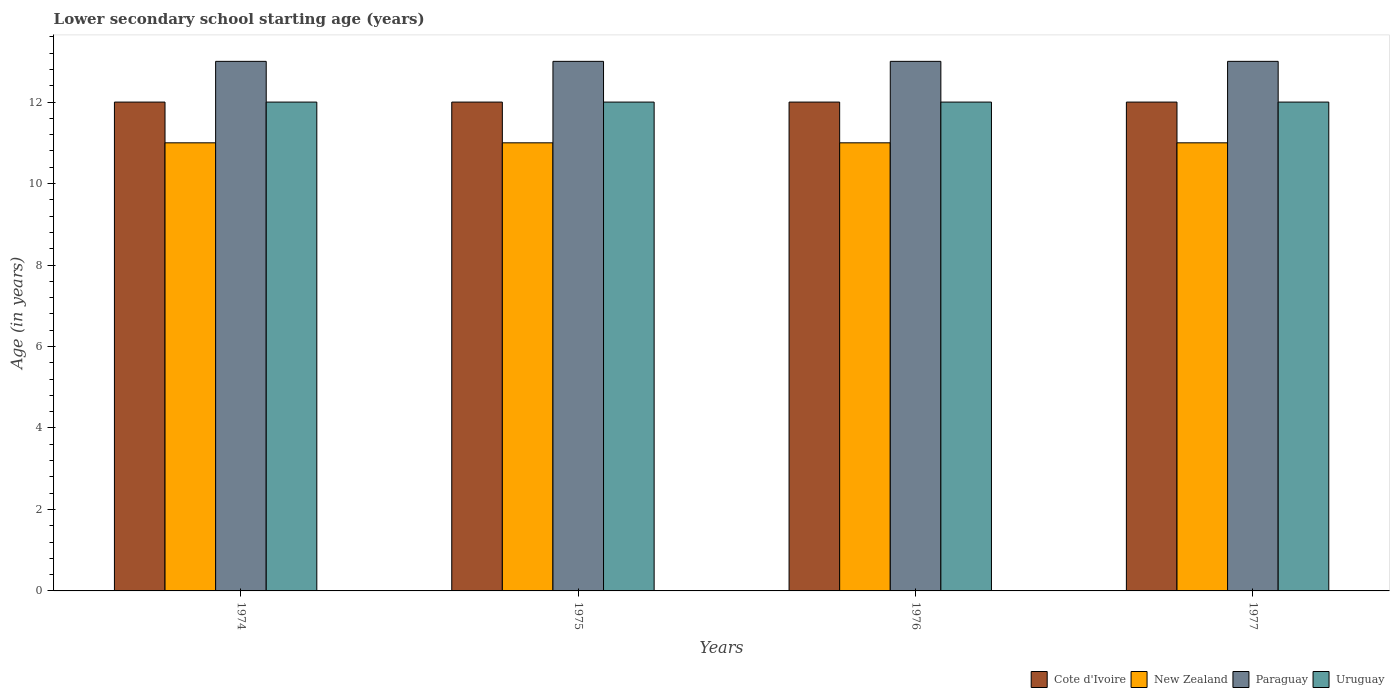How many groups of bars are there?
Provide a succinct answer. 4. Are the number of bars per tick equal to the number of legend labels?
Provide a succinct answer. Yes. Are the number of bars on each tick of the X-axis equal?
Offer a very short reply. Yes. How many bars are there on the 4th tick from the right?
Make the answer very short. 4. In how many cases, is the number of bars for a given year not equal to the number of legend labels?
Make the answer very short. 0. What is the lower secondary school starting age of children in New Zealand in 1977?
Provide a succinct answer. 11. Across all years, what is the maximum lower secondary school starting age of children in New Zealand?
Make the answer very short. 11. Across all years, what is the minimum lower secondary school starting age of children in Cote d'Ivoire?
Provide a succinct answer. 12. In which year was the lower secondary school starting age of children in Uruguay maximum?
Your answer should be very brief. 1974. In which year was the lower secondary school starting age of children in Cote d'Ivoire minimum?
Give a very brief answer. 1974. What is the total lower secondary school starting age of children in Paraguay in the graph?
Offer a terse response. 52. What is the difference between the lower secondary school starting age of children in Paraguay in 1974 and that in 1975?
Offer a very short reply. 0. What is the difference between the lower secondary school starting age of children in Cote d'Ivoire in 1975 and the lower secondary school starting age of children in New Zealand in 1976?
Provide a succinct answer. 1. What is the average lower secondary school starting age of children in Cote d'Ivoire per year?
Your response must be concise. 12. In the year 1976, what is the difference between the lower secondary school starting age of children in Uruguay and lower secondary school starting age of children in New Zealand?
Ensure brevity in your answer.  1. What is the ratio of the lower secondary school starting age of children in Cote d'Ivoire in 1976 to that in 1977?
Ensure brevity in your answer.  1. What is the difference between the highest and the second highest lower secondary school starting age of children in New Zealand?
Your response must be concise. 0. Is the sum of the lower secondary school starting age of children in Uruguay in 1974 and 1976 greater than the maximum lower secondary school starting age of children in Cote d'Ivoire across all years?
Provide a short and direct response. Yes. What does the 1st bar from the left in 1974 represents?
Give a very brief answer. Cote d'Ivoire. What does the 4th bar from the right in 1977 represents?
Your answer should be very brief. Cote d'Ivoire. Are all the bars in the graph horizontal?
Your response must be concise. No. How many years are there in the graph?
Offer a terse response. 4. Where does the legend appear in the graph?
Keep it short and to the point. Bottom right. How are the legend labels stacked?
Keep it short and to the point. Horizontal. What is the title of the graph?
Offer a terse response. Lower secondary school starting age (years). What is the label or title of the X-axis?
Your response must be concise. Years. What is the label or title of the Y-axis?
Keep it short and to the point. Age (in years). What is the Age (in years) in Cote d'Ivoire in 1974?
Your response must be concise. 12. What is the Age (in years) in New Zealand in 1974?
Offer a very short reply. 11. What is the Age (in years) in Paraguay in 1974?
Offer a terse response. 13. What is the Age (in years) of New Zealand in 1975?
Your response must be concise. 11. What is the Age (in years) of Cote d'Ivoire in 1976?
Give a very brief answer. 12. What is the Age (in years) of Uruguay in 1976?
Your response must be concise. 12. What is the Age (in years) in Uruguay in 1977?
Give a very brief answer. 12. Across all years, what is the maximum Age (in years) in Cote d'Ivoire?
Make the answer very short. 12. Across all years, what is the maximum Age (in years) of New Zealand?
Provide a short and direct response. 11. Across all years, what is the maximum Age (in years) in Paraguay?
Make the answer very short. 13. Across all years, what is the maximum Age (in years) of Uruguay?
Your answer should be very brief. 12. Across all years, what is the minimum Age (in years) in Cote d'Ivoire?
Give a very brief answer. 12. Across all years, what is the minimum Age (in years) of Paraguay?
Provide a short and direct response. 13. What is the total Age (in years) in New Zealand in the graph?
Keep it short and to the point. 44. What is the total Age (in years) in Paraguay in the graph?
Make the answer very short. 52. What is the total Age (in years) in Uruguay in the graph?
Your answer should be very brief. 48. What is the difference between the Age (in years) in Cote d'Ivoire in 1974 and that in 1975?
Your answer should be very brief. 0. What is the difference between the Age (in years) in New Zealand in 1974 and that in 1975?
Offer a terse response. 0. What is the difference between the Age (in years) in Paraguay in 1974 and that in 1975?
Your answer should be compact. 0. What is the difference between the Age (in years) of Cote d'Ivoire in 1974 and that in 1976?
Make the answer very short. 0. What is the difference between the Age (in years) in New Zealand in 1974 and that in 1976?
Your response must be concise. 0. What is the difference between the Age (in years) of Paraguay in 1974 and that in 1976?
Ensure brevity in your answer.  0. What is the difference between the Age (in years) in Uruguay in 1974 and that in 1976?
Give a very brief answer. 0. What is the difference between the Age (in years) in Cote d'Ivoire in 1974 and that in 1977?
Offer a terse response. 0. What is the difference between the Age (in years) in Uruguay in 1974 and that in 1977?
Offer a very short reply. 0. What is the difference between the Age (in years) in Paraguay in 1975 and that in 1976?
Give a very brief answer. 0. What is the difference between the Age (in years) in Uruguay in 1975 and that in 1976?
Make the answer very short. 0. What is the difference between the Age (in years) of Paraguay in 1975 and that in 1977?
Offer a terse response. 0. What is the difference between the Age (in years) of Uruguay in 1975 and that in 1977?
Make the answer very short. 0. What is the difference between the Age (in years) of Cote d'Ivoire in 1976 and that in 1977?
Offer a very short reply. 0. What is the difference between the Age (in years) in New Zealand in 1976 and that in 1977?
Your answer should be compact. 0. What is the difference between the Age (in years) in Cote d'Ivoire in 1974 and the Age (in years) in New Zealand in 1975?
Offer a very short reply. 1. What is the difference between the Age (in years) of New Zealand in 1974 and the Age (in years) of Uruguay in 1975?
Make the answer very short. -1. What is the difference between the Age (in years) in Cote d'Ivoire in 1974 and the Age (in years) in Paraguay in 1976?
Offer a terse response. -1. What is the difference between the Age (in years) of New Zealand in 1974 and the Age (in years) of Uruguay in 1976?
Keep it short and to the point. -1. What is the difference between the Age (in years) of Paraguay in 1974 and the Age (in years) of Uruguay in 1976?
Ensure brevity in your answer.  1. What is the difference between the Age (in years) in Cote d'Ivoire in 1974 and the Age (in years) in New Zealand in 1977?
Ensure brevity in your answer.  1. What is the difference between the Age (in years) of Cote d'Ivoire in 1974 and the Age (in years) of Paraguay in 1977?
Keep it short and to the point. -1. What is the difference between the Age (in years) in New Zealand in 1974 and the Age (in years) in Uruguay in 1977?
Provide a short and direct response. -1. What is the difference between the Age (in years) in Paraguay in 1974 and the Age (in years) in Uruguay in 1977?
Offer a terse response. 1. What is the difference between the Age (in years) in Cote d'Ivoire in 1975 and the Age (in years) in Paraguay in 1976?
Your response must be concise. -1. What is the difference between the Age (in years) in Cote d'Ivoire in 1975 and the Age (in years) in Uruguay in 1976?
Make the answer very short. 0. What is the difference between the Age (in years) of New Zealand in 1975 and the Age (in years) of Paraguay in 1976?
Make the answer very short. -2. What is the difference between the Age (in years) in Cote d'Ivoire in 1975 and the Age (in years) in New Zealand in 1977?
Ensure brevity in your answer.  1. What is the difference between the Age (in years) in Cote d'Ivoire in 1975 and the Age (in years) in Paraguay in 1977?
Offer a very short reply. -1. What is the difference between the Age (in years) in Cote d'Ivoire in 1975 and the Age (in years) in Uruguay in 1977?
Offer a very short reply. 0. What is the difference between the Age (in years) in New Zealand in 1976 and the Age (in years) in Uruguay in 1977?
Give a very brief answer. -1. What is the average Age (in years) in New Zealand per year?
Your response must be concise. 11. In the year 1974, what is the difference between the Age (in years) in Cote d'Ivoire and Age (in years) in New Zealand?
Provide a short and direct response. 1. In the year 1974, what is the difference between the Age (in years) of Cote d'Ivoire and Age (in years) of Paraguay?
Make the answer very short. -1. In the year 1974, what is the difference between the Age (in years) in Cote d'Ivoire and Age (in years) in Uruguay?
Your answer should be compact. 0. In the year 1974, what is the difference between the Age (in years) in Paraguay and Age (in years) in Uruguay?
Offer a terse response. 1. In the year 1975, what is the difference between the Age (in years) in Cote d'Ivoire and Age (in years) in New Zealand?
Ensure brevity in your answer.  1. In the year 1975, what is the difference between the Age (in years) of New Zealand and Age (in years) of Uruguay?
Your response must be concise. -1. In the year 1976, what is the difference between the Age (in years) of Cote d'Ivoire and Age (in years) of Paraguay?
Offer a terse response. -1. In the year 1976, what is the difference between the Age (in years) of Cote d'Ivoire and Age (in years) of Uruguay?
Ensure brevity in your answer.  0. In the year 1976, what is the difference between the Age (in years) in New Zealand and Age (in years) in Uruguay?
Your answer should be very brief. -1. In the year 1976, what is the difference between the Age (in years) of Paraguay and Age (in years) of Uruguay?
Your answer should be compact. 1. In the year 1977, what is the difference between the Age (in years) of Cote d'Ivoire and Age (in years) of New Zealand?
Your response must be concise. 1. In the year 1977, what is the difference between the Age (in years) in Cote d'Ivoire and Age (in years) in Paraguay?
Provide a short and direct response. -1. In the year 1977, what is the difference between the Age (in years) of Cote d'Ivoire and Age (in years) of Uruguay?
Offer a very short reply. 0. In the year 1977, what is the difference between the Age (in years) in Paraguay and Age (in years) in Uruguay?
Your answer should be very brief. 1. What is the ratio of the Age (in years) of Uruguay in 1974 to that in 1975?
Keep it short and to the point. 1. What is the ratio of the Age (in years) of Cote d'Ivoire in 1974 to that in 1976?
Make the answer very short. 1. What is the ratio of the Age (in years) of New Zealand in 1974 to that in 1976?
Make the answer very short. 1. What is the ratio of the Age (in years) of Paraguay in 1974 to that in 1976?
Your answer should be very brief. 1. What is the ratio of the Age (in years) in Uruguay in 1974 to that in 1977?
Ensure brevity in your answer.  1. What is the ratio of the Age (in years) in New Zealand in 1975 to that in 1976?
Offer a very short reply. 1. What is the ratio of the Age (in years) in Paraguay in 1975 to that in 1977?
Keep it short and to the point. 1. What is the ratio of the Age (in years) in Uruguay in 1975 to that in 1977?
Your response must be concise. 1. What is the ratio of the Age (in years) of Cote d'Ivoire in 1976 to that in 1977?
Give a very brief answer. 1. What is the ratio of the Age (in years) of New Zealand in 1976 to that in 1977?
Offer a very short reply. 1. What is the ratio of the Age (in years) of Paraguay in 1976 to that in 1977?
Offer a very short reply. 1. What is the ratio of the Age (in years) of Uruguay in 1976 to that in 1977?
Your answer should be very brief. 1. What is the difference between the highest and the second highest Age (in years) in New Zealand?
Give a very brief answer. 0. What is the difference between the highest and the second highest Age (in years) of Paraguay?
Provide a short and direct response. 0. What is the difference between the highest and the second highest Age (in years) in Uruguay?
Your response must be concise. 0. What is the difference between the highest and the lowest Age (in years) in Cote d'Ivoire?
Provide a succinct answer. 0. 